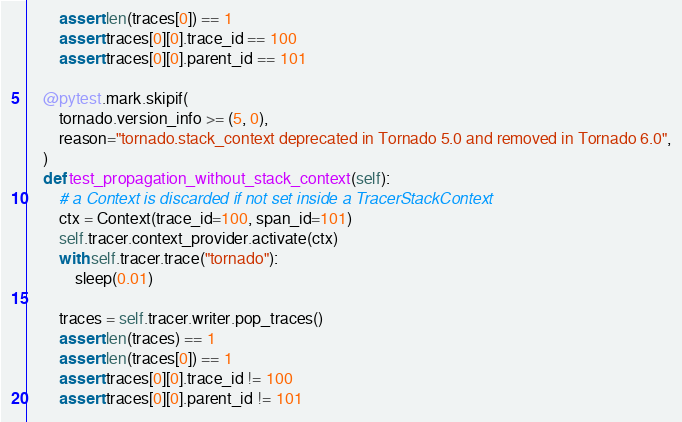Convert code to text. <code><loc_0><loc_0><loc_500><loc_500><_Python_>        assert len(traces[0]) == 1
        assert traces[0][0].trace_id == 100
        assert traces[0][0].parent_id == 101

    @pytest.mark.skipif(
        tornado.version_info >= (5, 0),
        reason="tornado.stack_context deprecated in Tornado 5.0 and removed in Tornado 6.0",
    )
    def test_propagation_without_stack_context(self):
        # a Context is discarded if not set inside a TracerStackContext
        ctx = Context(trace_id=100, span_id=101)
        self.tracer.context_provider.activate(ctx)
        with self.tracer.trace("tornado"):
            sleep(0.01)

        traces = self.tracer.writer.pop_traces()
        assert len(traces) == 1
        assert len(traces[0]) == 1
        assert traces[0][0].trace_id != 100
        assert traces[0][0].parent_id != 101
</code> 